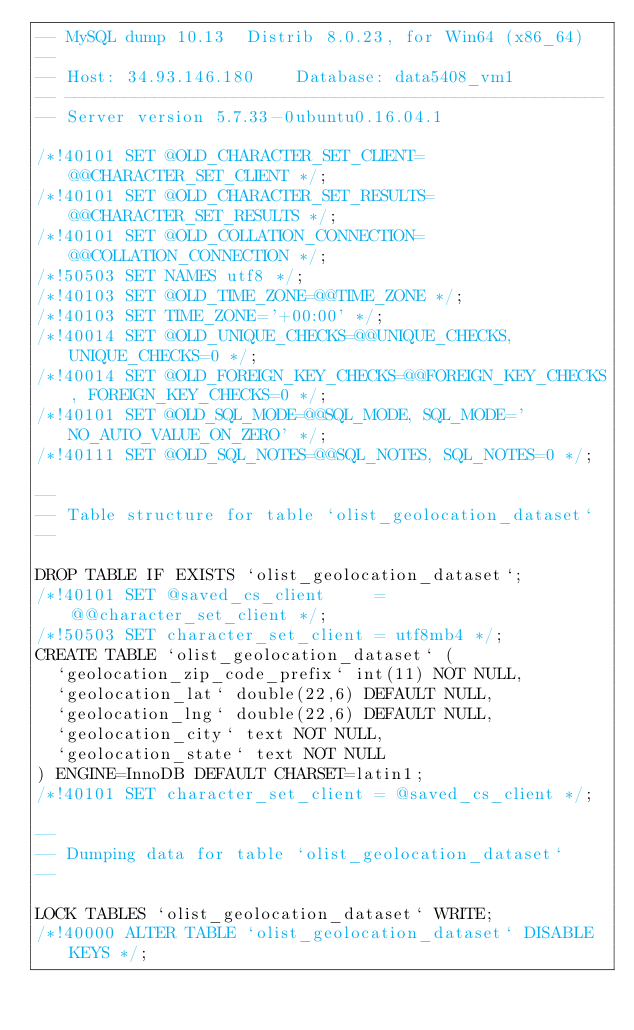<code> <loc_0><loc_0><loc_500><loc_500><_SQL_>-- MySQL dump 10.13  Distrib 8.0.23, for Win64 (x86_64)
--
-- Host: 34.93.146.180    Database: data5408_vm1
-- ------------------------------------------------------
-- Server version	5.7.33-0ubuntu0.16.04.1

/*!40101 SET @OLD_CHARACTER_SET_CLIENT=@@CHARACTER_SET_CLIENT */;
/*!40101 SET @OLD_CHARACTER_SET_RESULTS=@@CHARACTER_SET_RESULTS */;
/*!40101 SET @OLD_COLLATION_CONNECTION=@@COLLATION_CONNECTION */;
/*!50503 SET NAMES utf8 */;
/*!40103 SET @OLD_TIME_ZONE=@@TIME_ZONE */;
/*!40103 SET TIME_ZONE='+00:00' */;
/*!40014 SET @OLD_UNIQUE_CHECKS=@@UNIQUE_CHECKS, UNIQUE_CHECKS=0 */;
/*!40014 SET @OLD_FOREIGN_KEY_CHECKS=@@FOREIGN_KEY_CHECKS, FOREIGN_KEY_CHECKS=0 */;
/*!40101 SET @OLD_SQL_MODE=@@SQL_MODE, SQL_MODE='NO_AUTO_VALUE_ON_ZERO' */;
/*!40111 SET @OLD_SQL_NOTES=@@SQL_NOTES, SQL_NOTES=0 */;

--
-- Table structure for table `olist_geolocation_dataset`
--

DROP TABLE IF EXISTS `olist_geolocation_dataset`;
/*!40101 SET @saved_cs_client     = @@character_set_client */;
/*!50503 SET character_set_client = utf8mb4 */;
CREATE TABLE `olist_geolocation_dataset` (
  `geolocation_zip_code_prefix` int(11) NOT NULL,
  `geolocation_lat` double(22,6) DEFAULT NULL,
  `geolocation_lng` double(22,6) DEFAULT NULL,
  `geolocation_city` text NOT NULL,
  `geolocation_state` text NOT NULL
) ENGINE=InnoDB DEFAULT CHARSET=latin1;
/*!40101 SET character_set_client = @saved_cs_client */;

--
-- Dumping data for table `olist_geolocation_dataset`
--

LOCK TABLES `olist_geolocation_dataset` WRITE;
/*!40000 ALTER TABLE `olist_geolocation_dataset` DISABLE KEYS */;</code> 